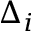<formula> <loc_0><loc_0><loc_500><loc_500>\Delta _ { i }</formula> 